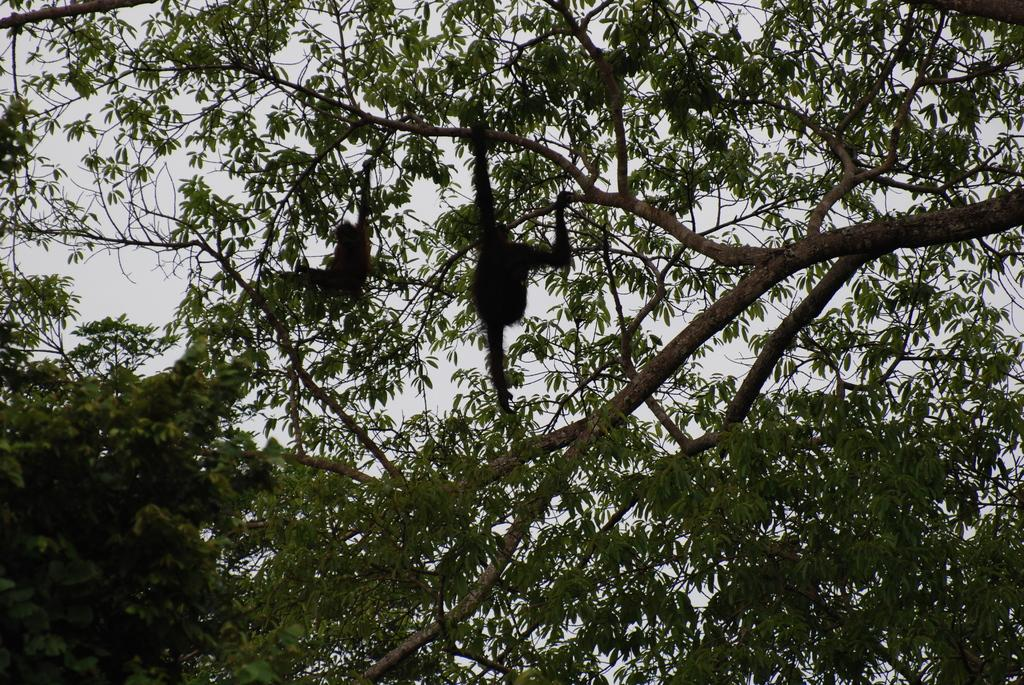How many monkeys are present in the image? There are two monkeys in the image. Where are the monkeys located? The monkeys are on a tree. What type of sock is the monkey wearing on its left foot in the image? There are no socks present in the image, as the monkeys are not wearing any clothing. 